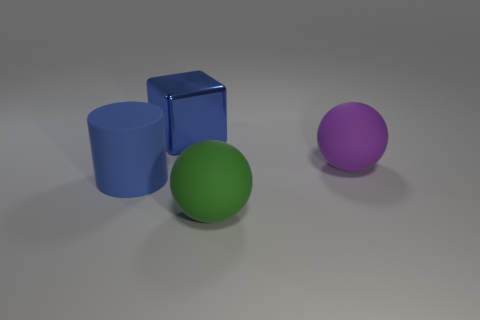There is a object behind the big purple ball; is its shape the same as the blue matte object?
Provide a short and direct response. No. There is a green thing that is the same shape as the large purple thing; what is its material?
Provide a succinct answer. Rubber. How many blue rubber objects are the same size as the blue metal object?
Offer a terse response. 1. There is a big matte thing that is right of the metallic cube and in front of the purple rubber thing; what color is it?
Your answer should be compact. Green. Are there fewer large gray metal spheres than big purple balls?
Offer a very short reply. Yes. There is a big cylinder; does it have the same color as the big ball that is in front of the purple matte ball?
Offer a very short reply. No. Is the number of big blue cubes on the right side of the large block the same as the number of big green balls that are behind the large cylinder?
Provide a short and direct response. Yes. How many large blue shiny things are the same shape as the big green matte thing?
Your response must be concise. 0. Are any purple metallic balls visible?
Keep it short and to the point. No. Are the big cylinder and the ball that is to the right of the green sphere made of the same material?
Make the answer very short. Yes. 